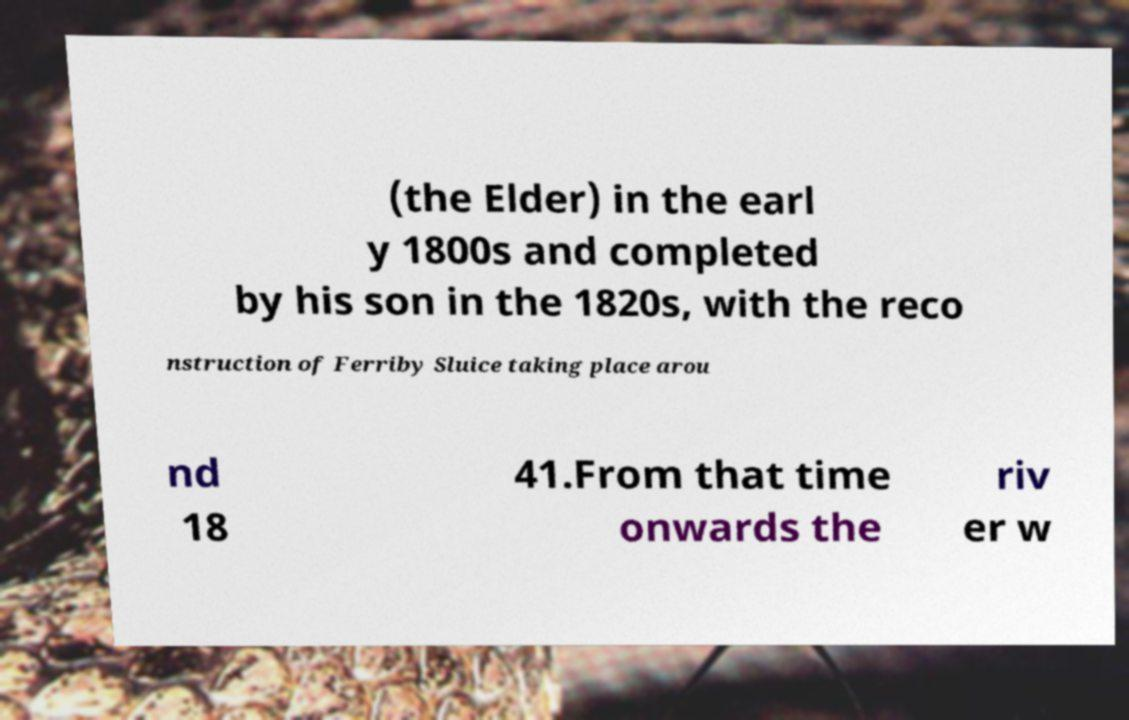There's text embedded in this image that I need extracted. Can you transcribe it verbatim? (the Elder) in the earl y 1800s and completed by his son in the 1820s, with the reco nstruction of Ferriby Sluice taking place arou nd 18 41.From that time onwards the riv er w 